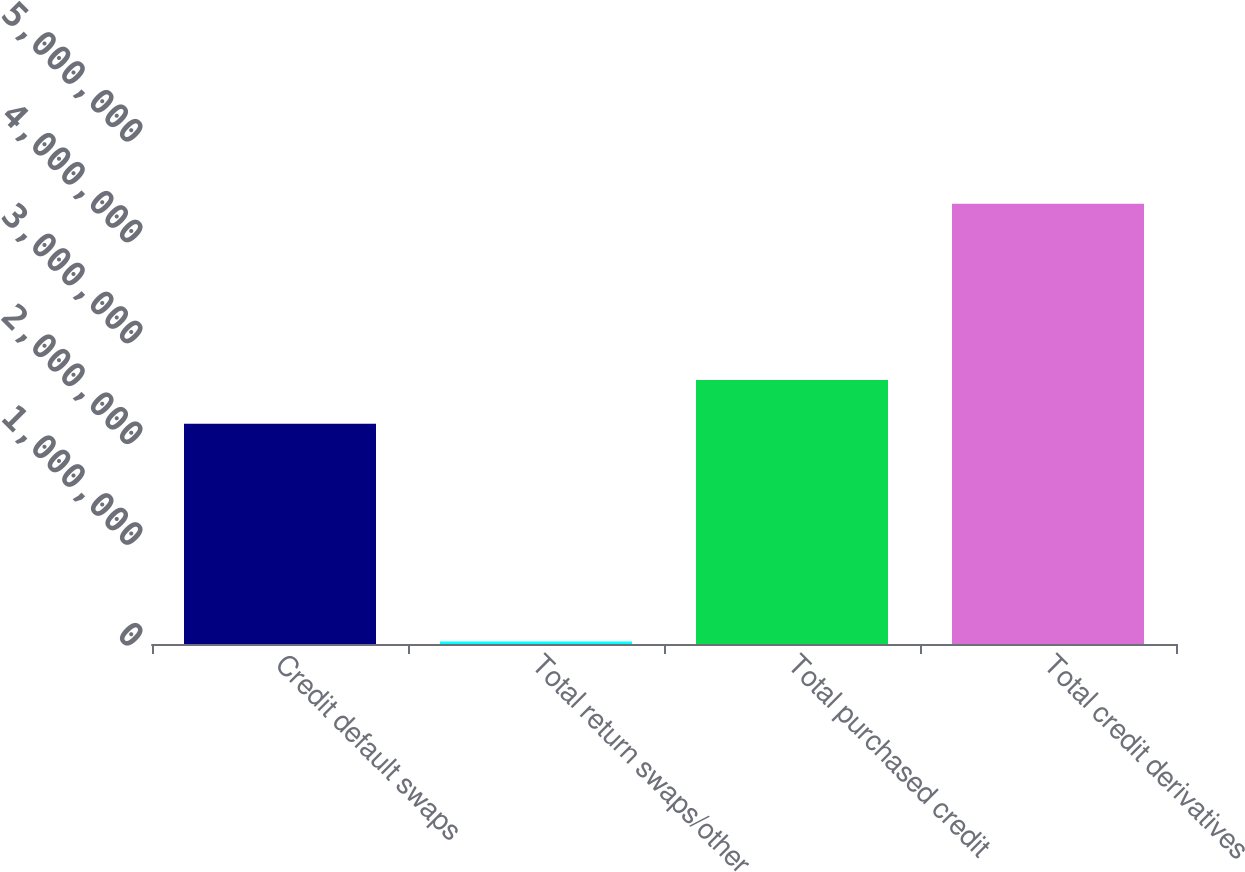<chart> <loc_0><loc_0><loc_500><loc_500><bar_chart><fcel>Credit default swaps<fcel>Total return swaps/other<fcel>Total purchased credit<fcel>Total credit derivatives<nl><fcel>2.1847e+06<fcel>26038<fcel>2.61877e+06<fcel>4.3667e+06<nl></chart> 